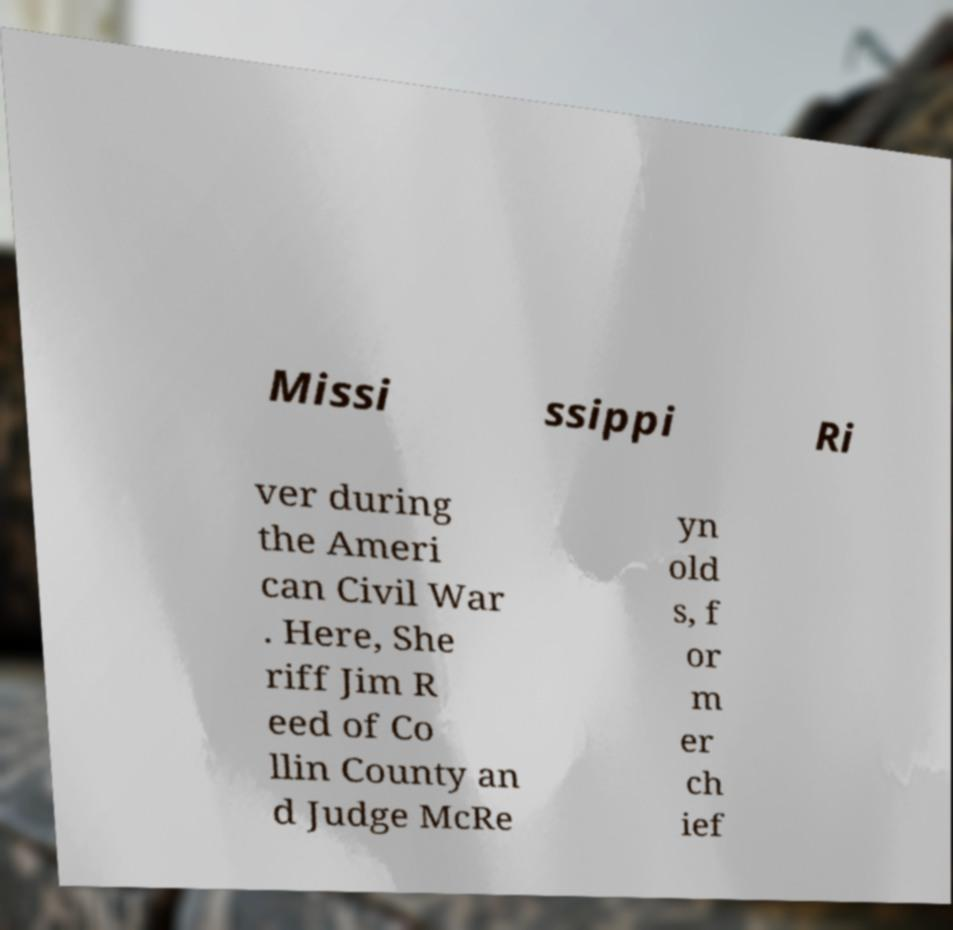Can you read and provide the text displayed in the image?This photo seems to have some interesting text. Can you extract and type it out for me? Missi ssippi Ri ver during the Ameri can Civil War . Here, She riff Jim R eed of Co llin County an d Judge McRe yn old s, f or m er ch ief 